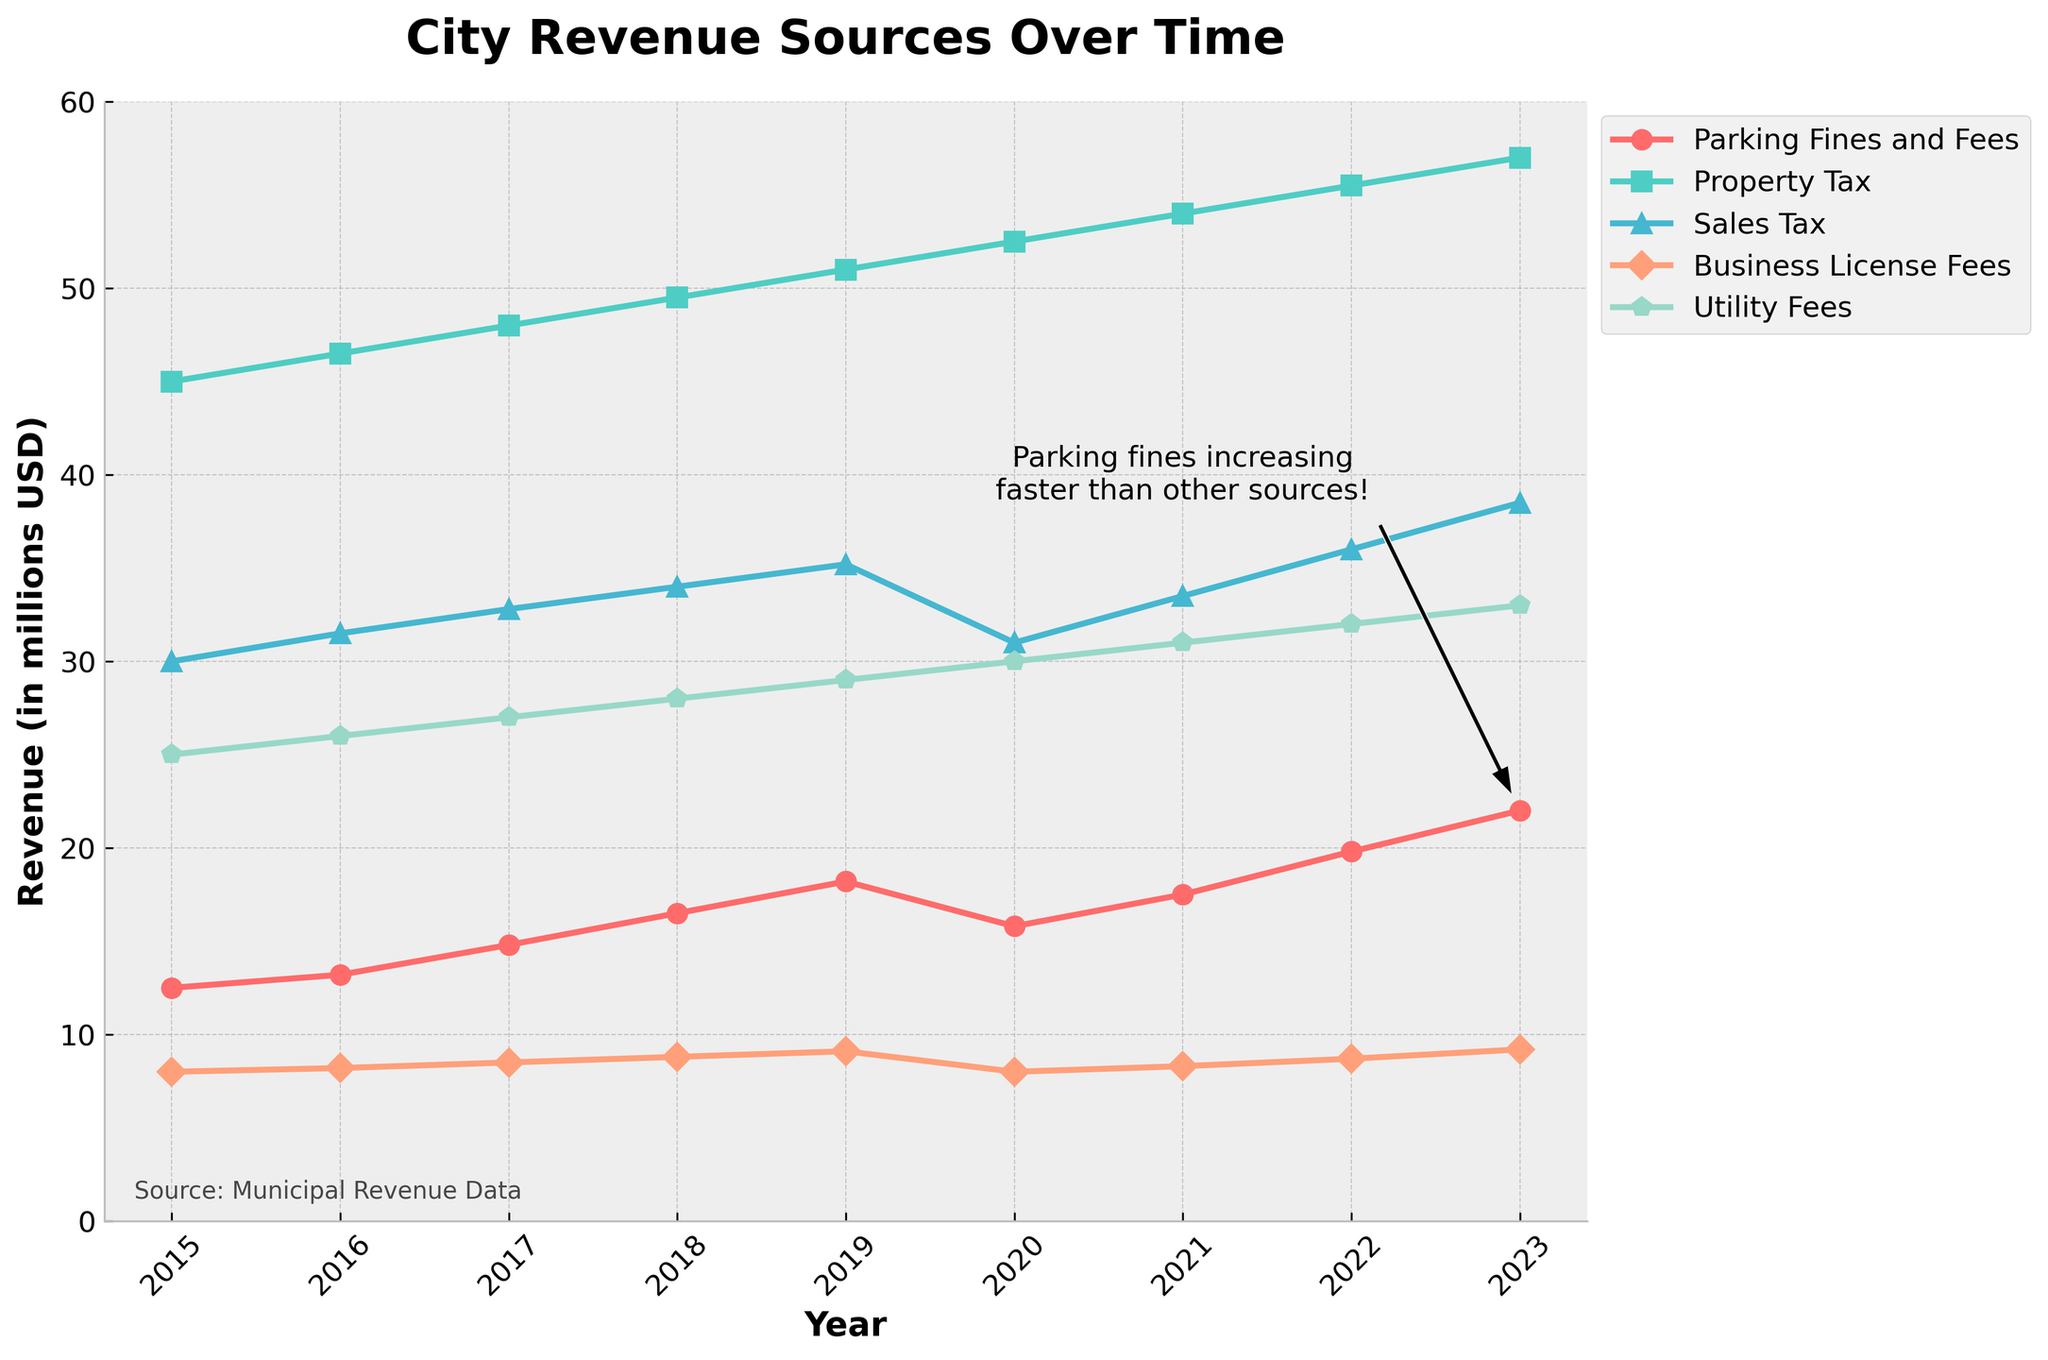What is the overall trend of revenue from parking fines and fees over the years? The plot shows an overall increasing trend in the revenue from parking fines and fees from 2015 to 2023, with a slight decline in 2020.
Answer: Increasing Which year saw a decrease in parking fines and fees revenue compared to the previous year? According to the chart, the year 2020 shows a decrease in parking fines and fees compared to 2019.
Answer: 2020 How much did parking fines and fees increase from 2015 to 2023? From the chart, the revenue from parking fines and fees was $12,500,000 in 2015 and increased to $22,000,000 in 2023. Therefore, the increase is $22,000,000 - $12,500,000 = $9,500,000.
Answer: $9,500,000 In 2023, how does the revenue from parking fines and fees compare to sales tax revenue? The chart shows that in 2023, parking fines and fees revenue is $22,000,000 and sales tax revenue is $38,500,000. Parking fines and fees are lower than sales tax revenue by $16,500,000.
Answer: Lower by $16,500,000 Which revenue source had the least growth from 2015 to 2023? By examining the trend lines, Business License Fees show the smallest increase from $8,000,000 in 2015 to $9,200,000 in 2023.
Answer: Business License Fees What is the average annual revenue from property tax between 2016 and 2020? The annual revenues are $46,500,000 (2016), $48,000,000 (2017), $49,500,000 (2018), $51,000,000 (2019), and $52,500,000 (2020). The average is calculated as ($46,500,000 + $48,000,000 + $49,500,000 + $51,000,000 + $52,500,000) / 5 = $49,900,000.
Answer: $49,900,000 Which year had the highest utility fees, and which had the lowest within the data range? From the chart, 2023 had the highest utility fees at $33,000,000, and 2015 had the lowest at $25,000,000.
Answer: Highest: 2023, Lowest: 2015 How does 2022's total revenue from parking fines and fees, property tax, and sales tax compare to 2017's total revenue from the same sources? In 2022, the total revenue from the three sources is $19,800,000 (parking) + $55,000,000 (property tax) + $36,000,000 (sales tax) = $110,800,000. In 2017, it is $14,800,000 (parking) + $48,000,000 (property tax) + $32,800,000 (sales tax) = $95,600,000. Comparing these, 2022's total is higher by $110,800,000 - $95,600,000 = $15,200,000.
Answer: 2022 is higher by $15,200,000 